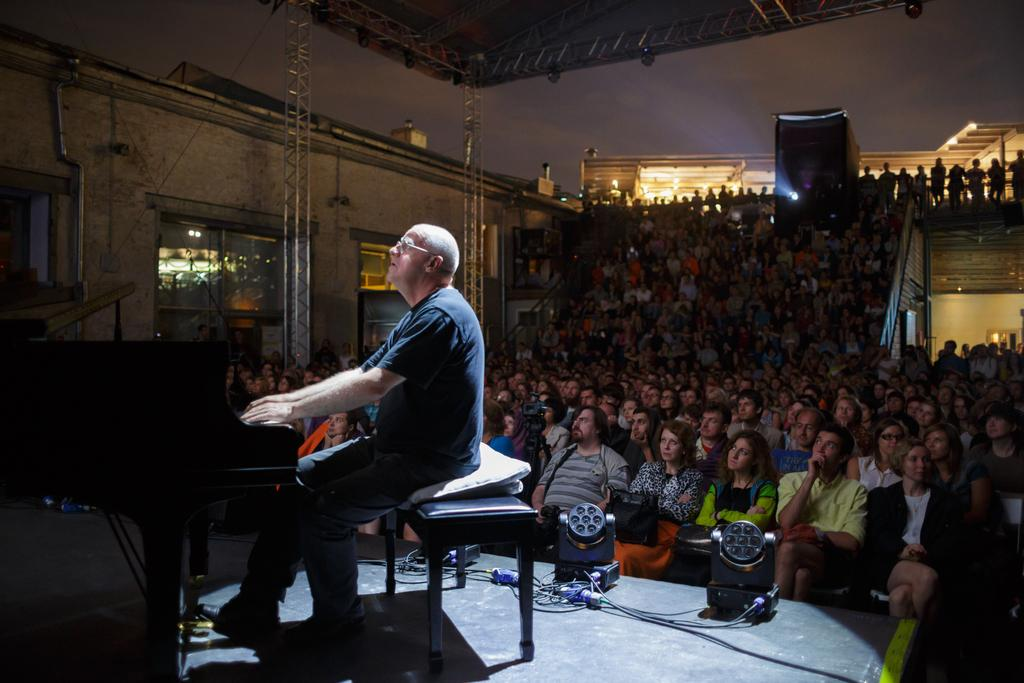What is the person in the image doing? The person is sitting and playing a keyboard. Are there any other people in the image? Yes, there are many people sitting behind the person playing the keyboard. What type of orange is the carpenter holding in the image? There is no carpenter or orange present in the image. 